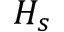<formula> <loc_0><loc_0><loc_500><loc_500>H _ { s }</formula> 